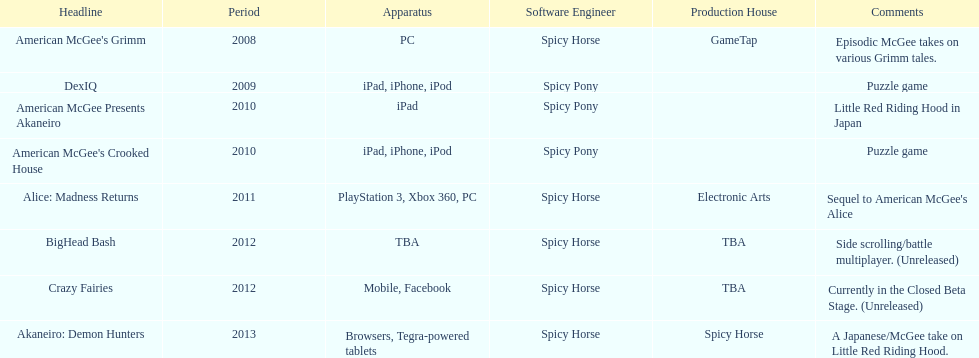What is the first title on this chart? American McGee's Grimm. 